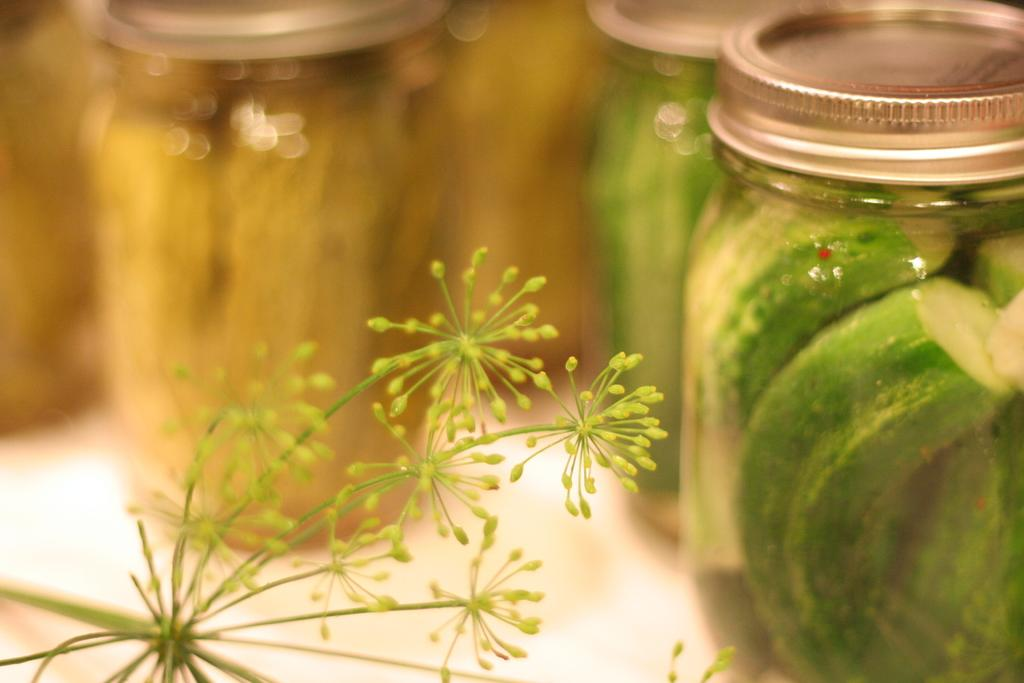What type of plant is present on the left side of the image? There are dandelions on the left side of the image. What can be found on the right side of the image? There are jars with pickles on the right side of the image. Where is the cactus located in the image? There is no cactus present in the image. What type of plant is used to start a car in the image? There is no plant used to start a car in the image. 